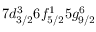Convert formula to latex. <formula><loc_0><loc_0><loc_500><loc_500>7 d _ { 3 / 2 } ^ { 3 } 6 f _ { 5 / 2 } ^ { 1 } 5 g _ { 9 / 2 } ^ { 6 }</formula> 